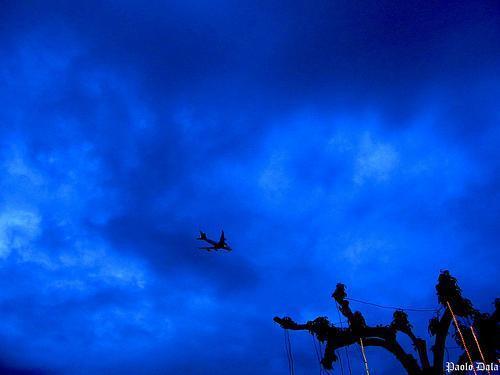How many planes are in the sky?
Give a very brief answer. 1. 